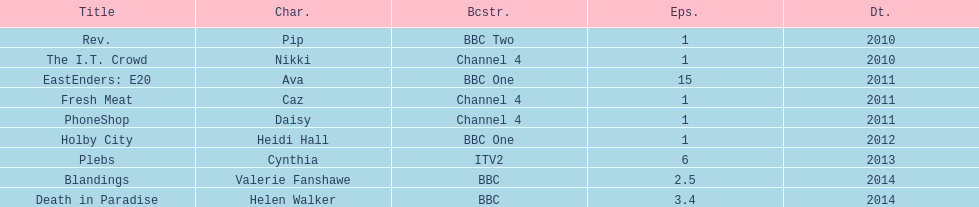Blandings and death in paradise both aired on which broadcaster? BBC. 